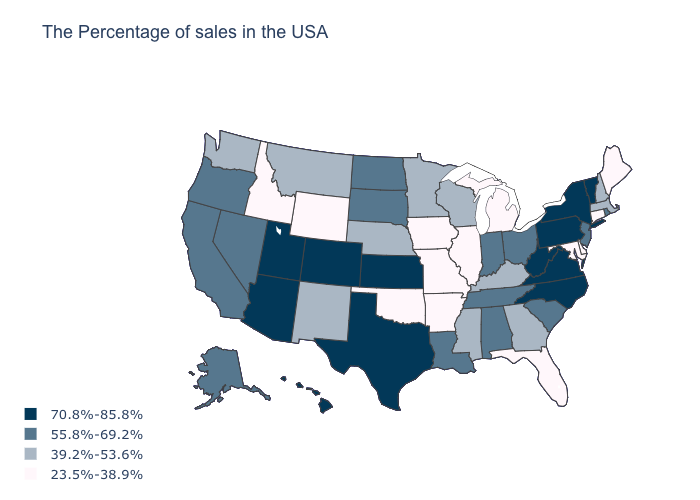Does the first symbol in the legend represent the smallest category?
Concise answer only. No. What is the highest value in the MidWest ?
Short answer required. 70.8%-85.8%. Is the legend a continuous bar?
Answer briefly. No. Name the states that have a value in the range 55.8%-69.2%?
Keep it brief. Rhode Island, New Jersey, South Carolina, Ohio, Indiana, Alabama, Tennessee, Louisiana, South Dakota, North Dakota, Nevada, California, Oregon, Alaska. Is the legend a continuous bar?
Write a very short answer. No. Which states have the lowest value in the South?
Give a very brief answer. Delaware, Maryland, Florida, Arkansas, Oklahoma. Among the states that border Washington , which have the highest value?
Concise answer only. Oregon. What is the value of New Jersey?
Short answer required. 55.8%-69.2%. Which states have the lowest value in the MidWest?
Keep it brief. Michigan, Illinois, Missouri, Iowa. Name the states that have a value in the range 39.2%-53.6%?
Concise answer only. Massachusetts, New Hampshire, Georgia, Kentucky, Wisconsin, Mississippi, Minnesota, Nebraska, New Mexico, Montana, Washington. What is the value of Texas?
Write a very short answer. 70.8%-85.8%. Does New Hampshire have the highest value in the USA?
Be succinct. No. Does Indiana have the same value as Texas?
Quick response, please. No. Does the first symbol in the legend represent the smallest category?
Give a very brief answer. No. Name the states that have a value in the range 70.8%-85.8%?
Quick response, please. Vermont, New York, Pennsylvania, Virginia, North Carolina, West Virginia, Kansas, Texas, Colorado, Utah, Arizona, Hawaii. 